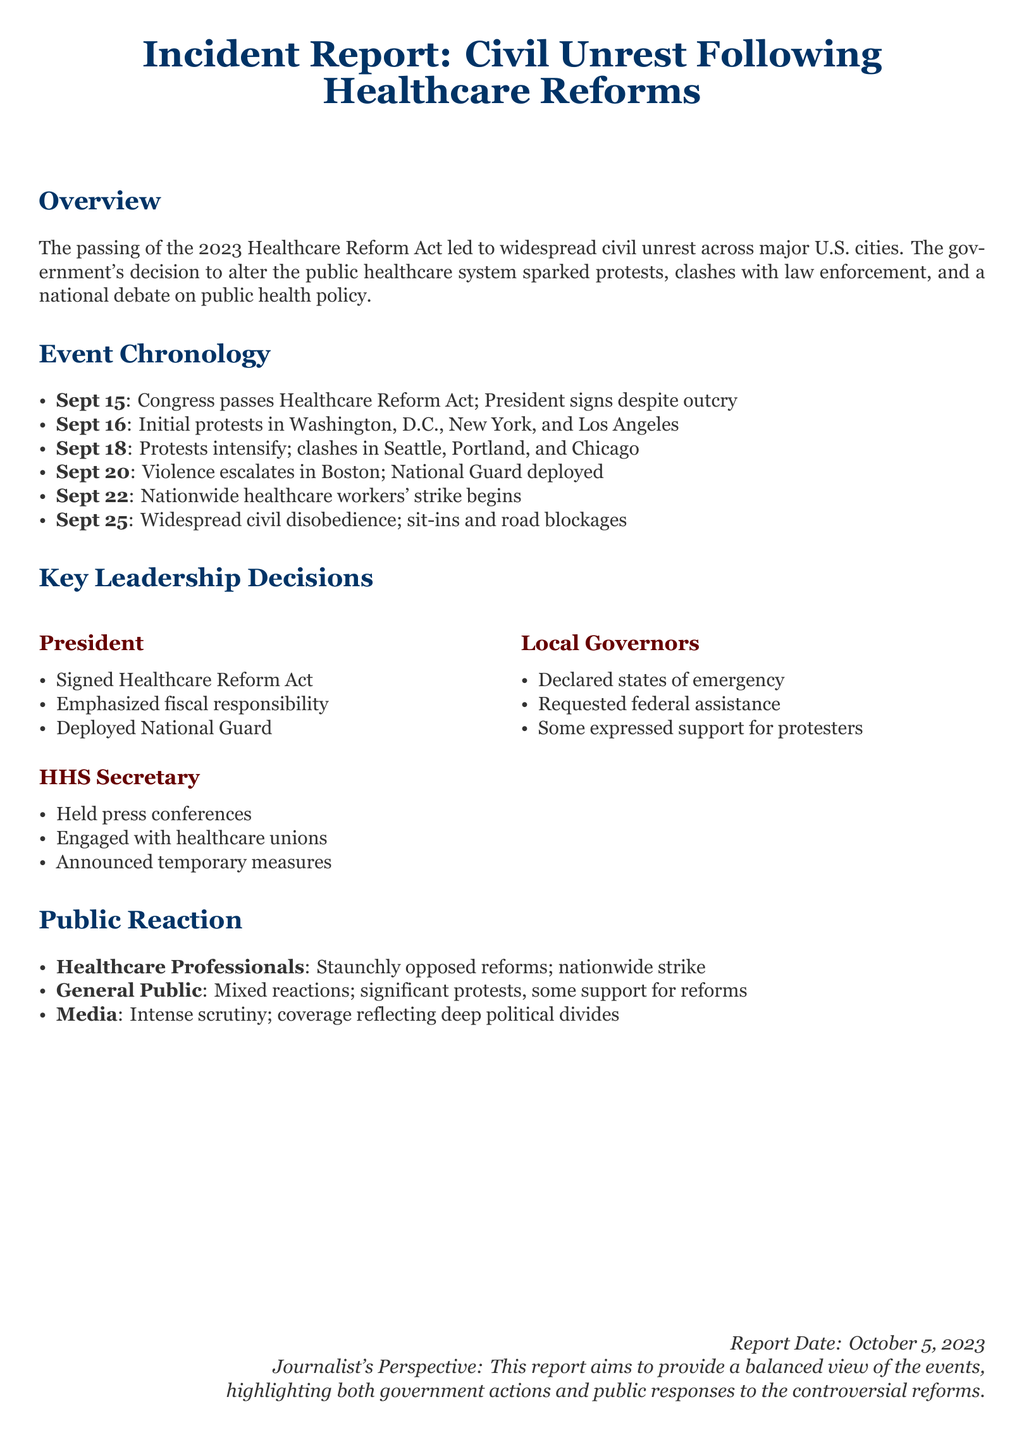What event sparked the civil unrest? The event that sparked the civil unrest was the passing of the 2023 Healthcare Reform Act.
Answer: 2023 Healthcare Reform Act When did the initial protests occur? The initial protests occurred on September 16.
Answer: September 16 Which city saw violence escalate on September 20? Violence escalated in Boston on September 20.
Answer: Boston What was one of the key decisions made by the HHS Secretary? One key decision made by the HHS Secretary was to hold press conferences.
Answer: Held press conferences What action did some local governors take in response to the unrest? Some local governors declared states of emergency in response to the unrest.
Answer: Declared states of emergency Which group of professionals opposed the healthcare reforms? Healthcare professionals opposed the healthcare reforms.
Answer: Healthcare professionals What type of public reaction was significant during the protests? The significant public reaction included nationwide protests against the reforms.
Answer: Nationwide protests What date was this incident report published? The incident report was published on October 5, 2023.
Answer: October 5, 2023 What was one major theme covered by the media regarding the unrest? One major theme covered by the media was intense scrutiny of the government's actions.
Answer: Intense scrutiny 